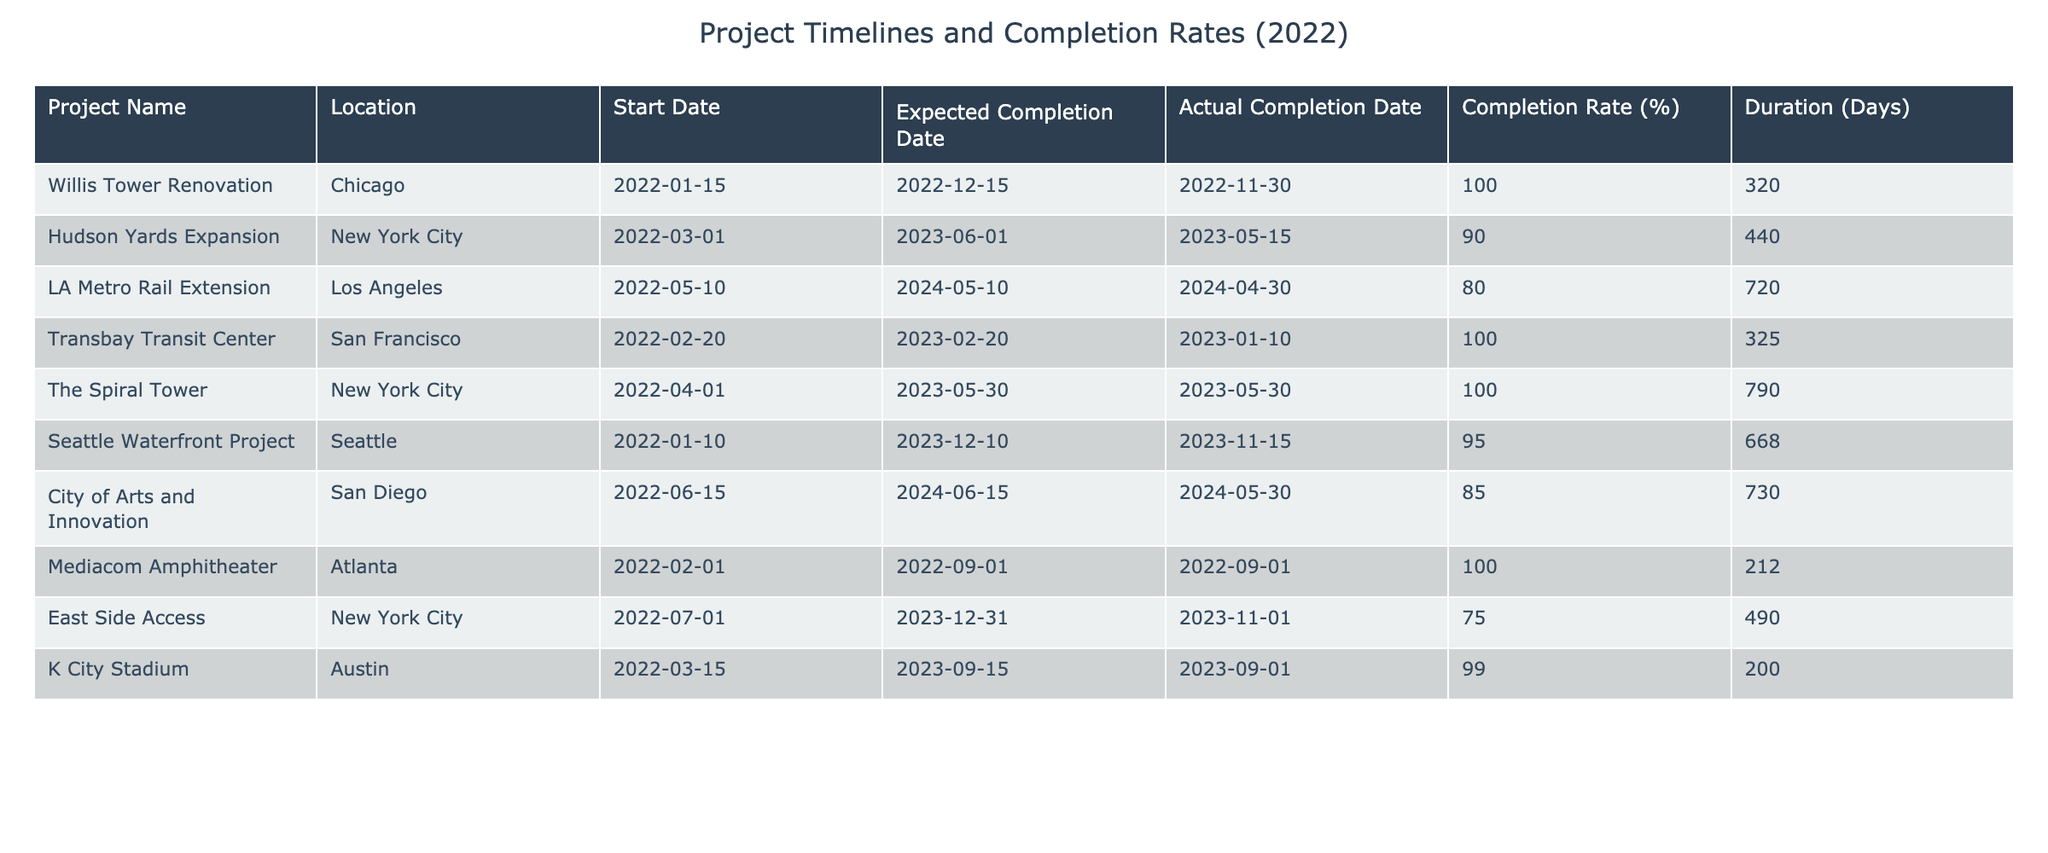What is the completion rate of the Willis Tower Renovation? The table indicates the completion rate of the Willis Tower Renovation is listed as 100%.
Answer: 100% Which project had the longest duration? By comparing the "Duration (Days)" column, the LA Metro Rail Extension has the highest duration, totaling 720 days.
Answer: LA Metro Rail Extension Did the East Side Access project meet its expected completion date? The "Expected Completion Date" is December 31, 2023, while the "Actual Completion Date" is November 1, 2023, meaning it was completed ahead of schedule.
Answer: Yes What is the average completion rate of projects located in New York City? The completion rates for New York City projects are 100%, 90%, and 75%. Adding these gives 100 + 90 + 75 = 265. Dividing by 3 gives an average of 265 / 3 = 88.33%.
Answer: 88.33% Which project has the shortest duration, and what is that duration? The Mediacom Amphitheater has the shortest duration of 212 days. By inspecting the "Duration (Days)" column, it's clear this is the lowest value.
Answer: 212 Days How many projects were completed with a completion rate of 100%? From the "Completion Rate (%)" column, the projects with a 100% completion rate are Willis Tower Renovation, Transbay Transit Center, and Mediacom Amphitheater, totaling three projects.
Answer: 3 Is the completion rate of the City of Arts and Innovation project above 80%? The completion rate for the City of Arts and Innovation is listed as 85%, which is indeed above 80%.
Answer: Yes What is the range of completion rates across all projects listed? The highest completion rate is 100%, and the lowest is 75%. To find the range, subtract the lowest from the highest: 100 - 75 = 25.
Answer: 25% 